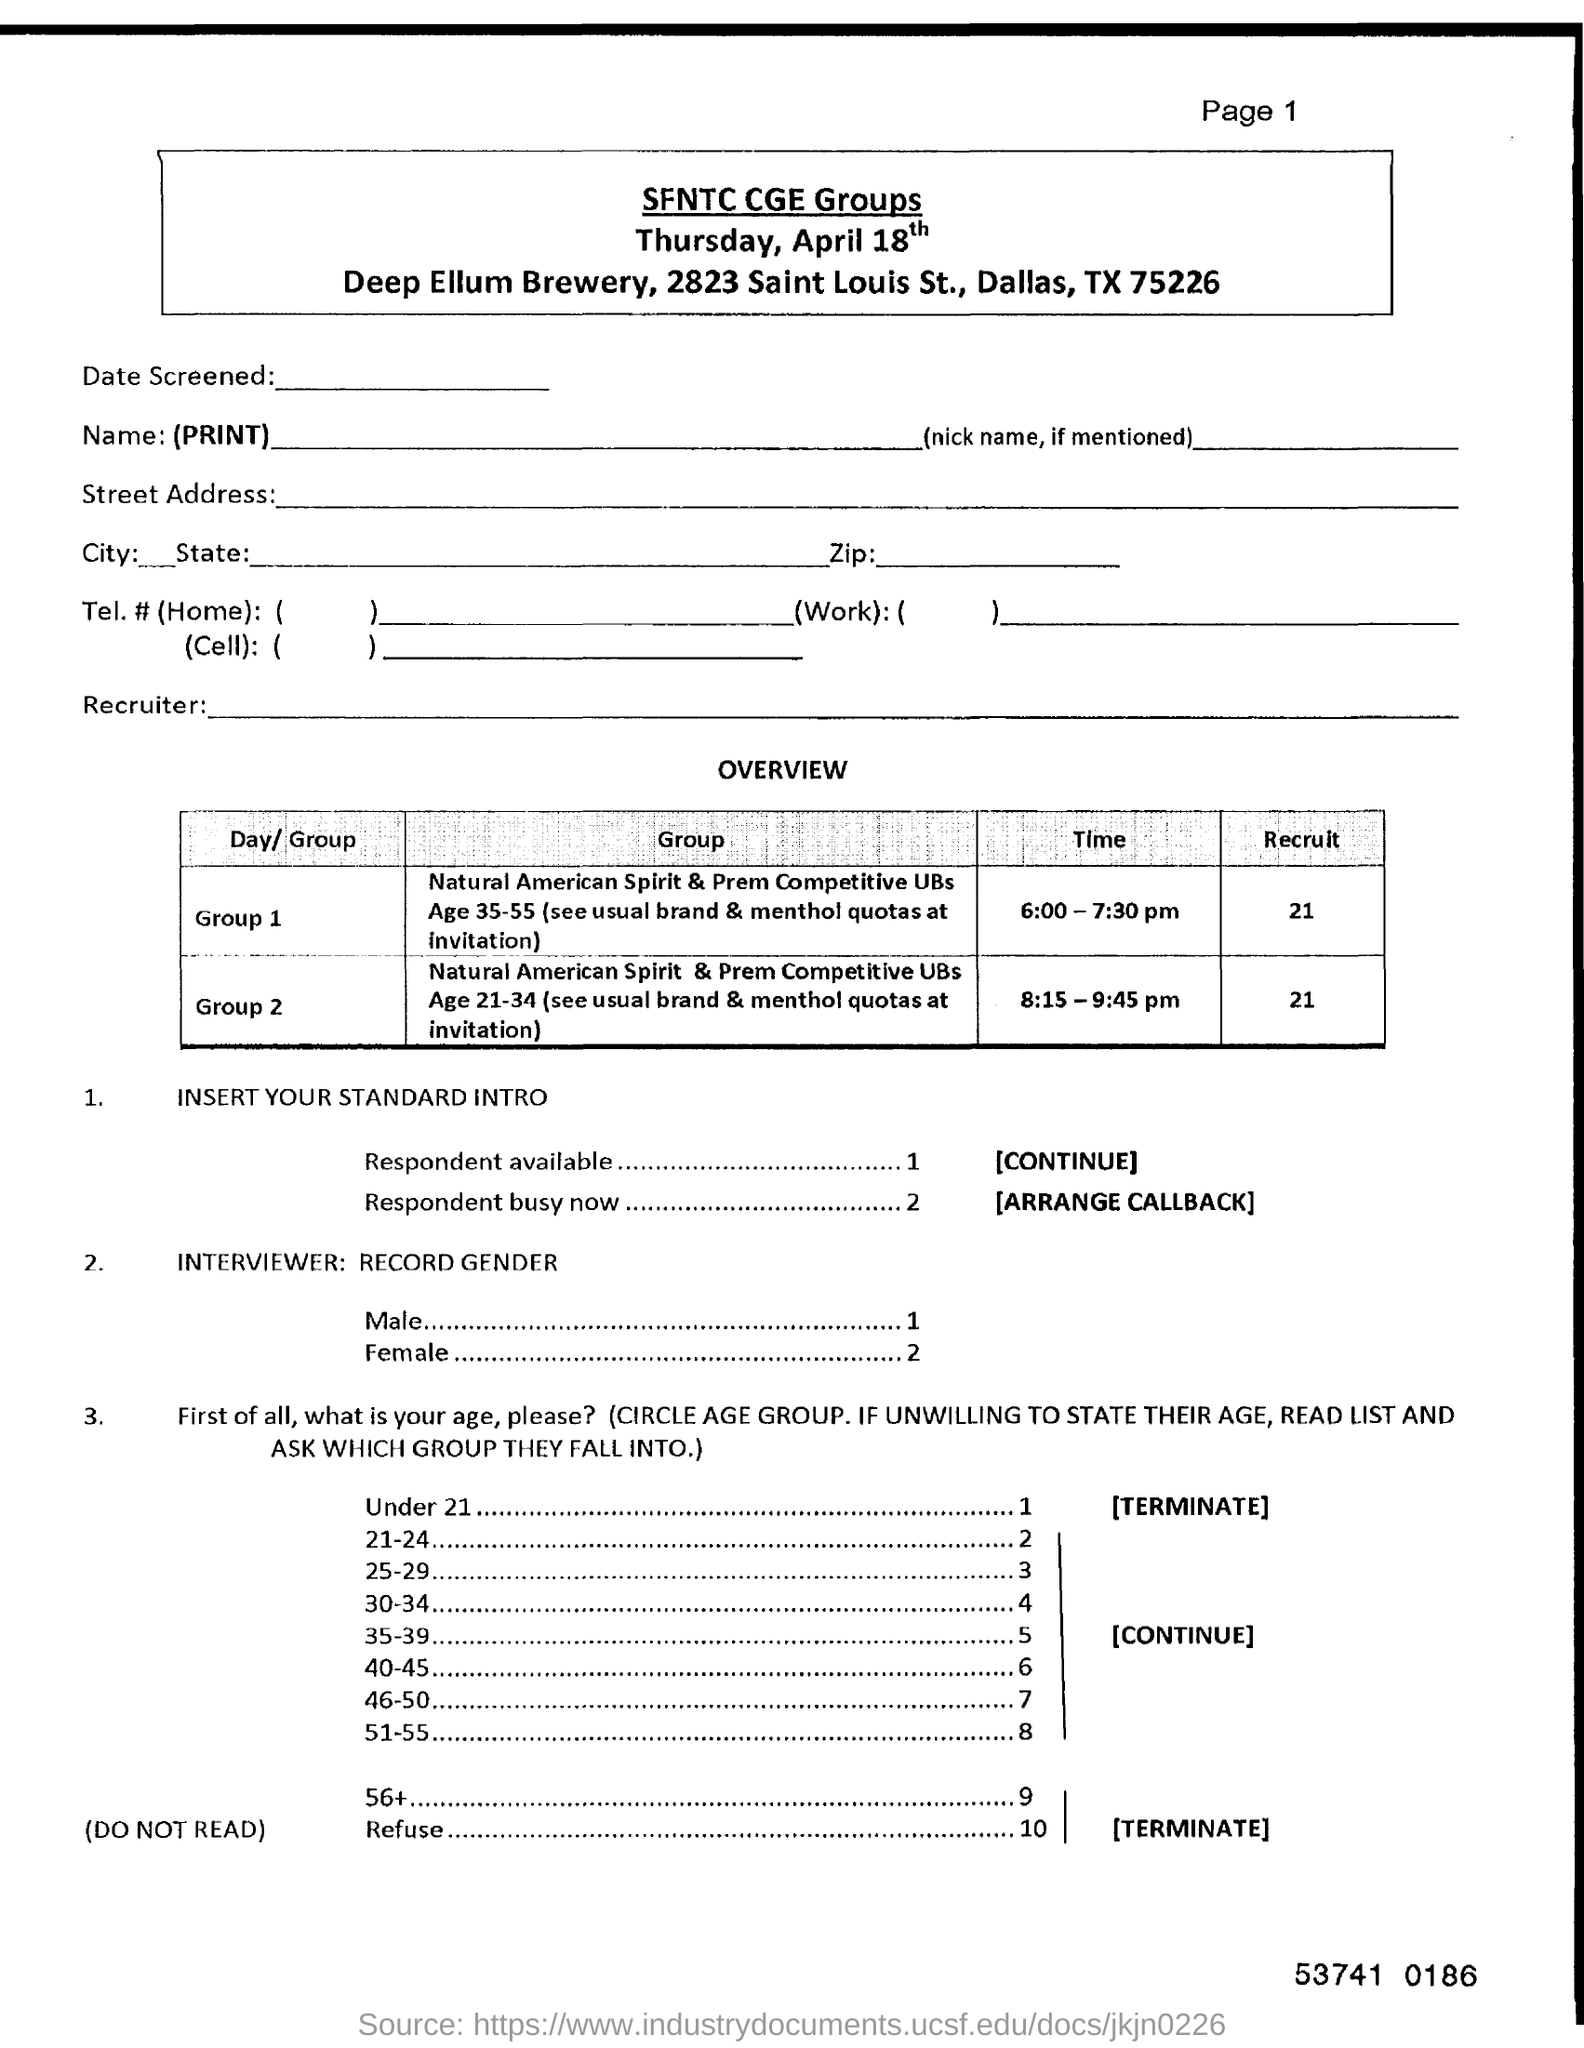What is the zip code mentioned?
Provide a succinct answer. 75226. What is the page number on this document?
Offer a very short reply. Page 1. How many recruits in Group 1?
Ensure brevity in your answer.  21. What is the number written at the bottom of the page?
Keep it short and to the point. 53741 0186. 